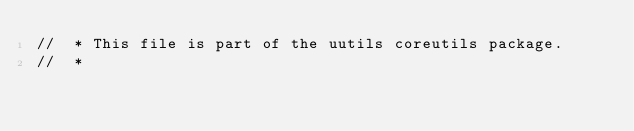Convert code to text. <code><loc_0><loc_0><loc_500><loc_500><_Rust_>//  * This file is part of the uutils coreutils package.
//  *</code> 